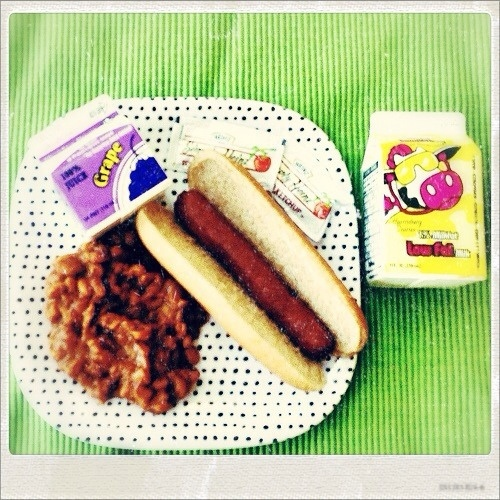Describe the objects in this image and their specific colors. I can see a hot dog in gray, khaki, lightyellow, maroon, and brown tones in this image. 